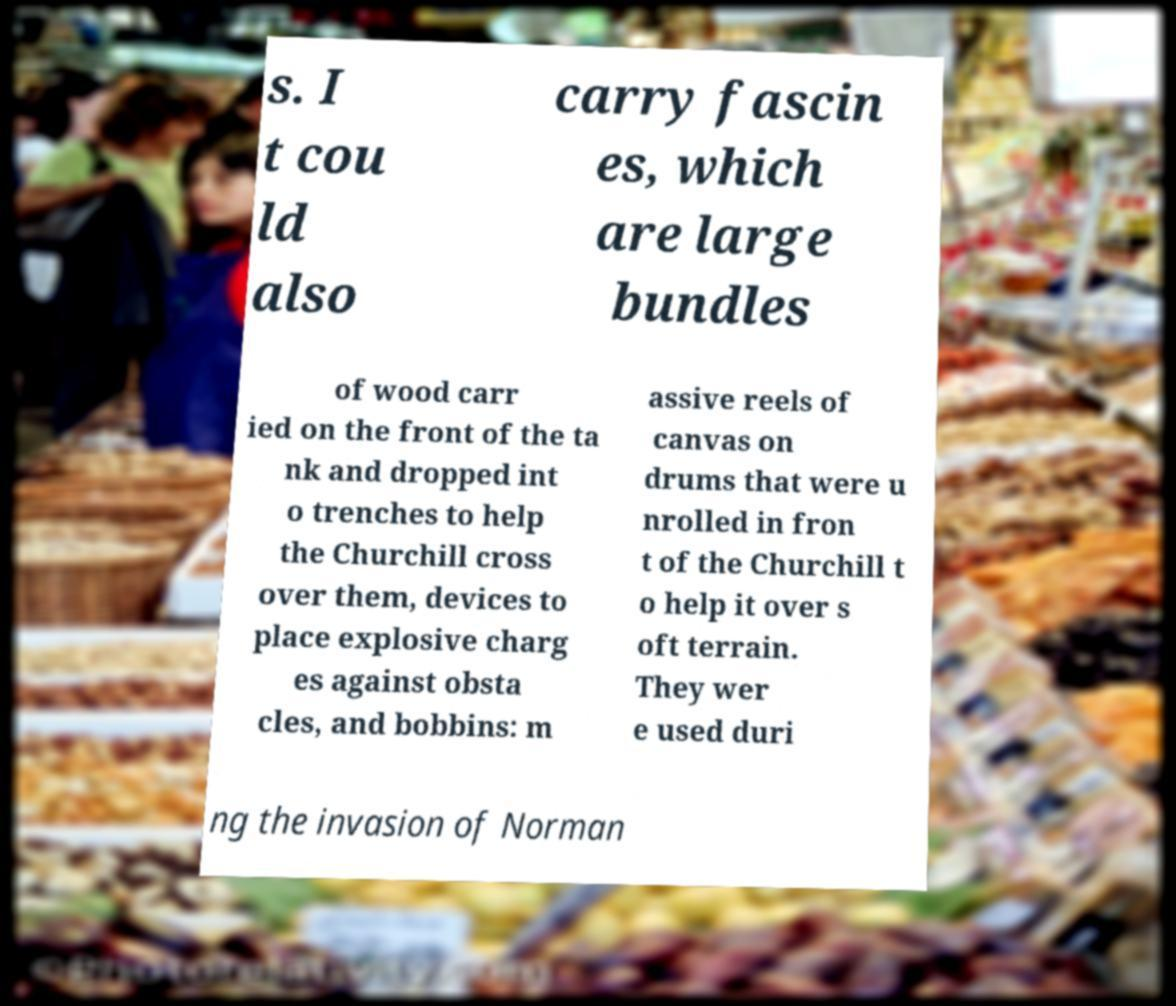What messages or text are displayed in this image? I need them in a readable, typed format. s. I t cou ld also carry fascin es, which are large bundles of wood carr ied on the front of the ta nk and dropped int o trenches to help the Churchill cross over them, devices to place explosive charg es against obsta cles, and bobbins: m assive reels of canvas on drums that were u nrolled in fron t of the Churchill t o help it over s oft terrain. They wer e used duri ng the invasion of Norman 